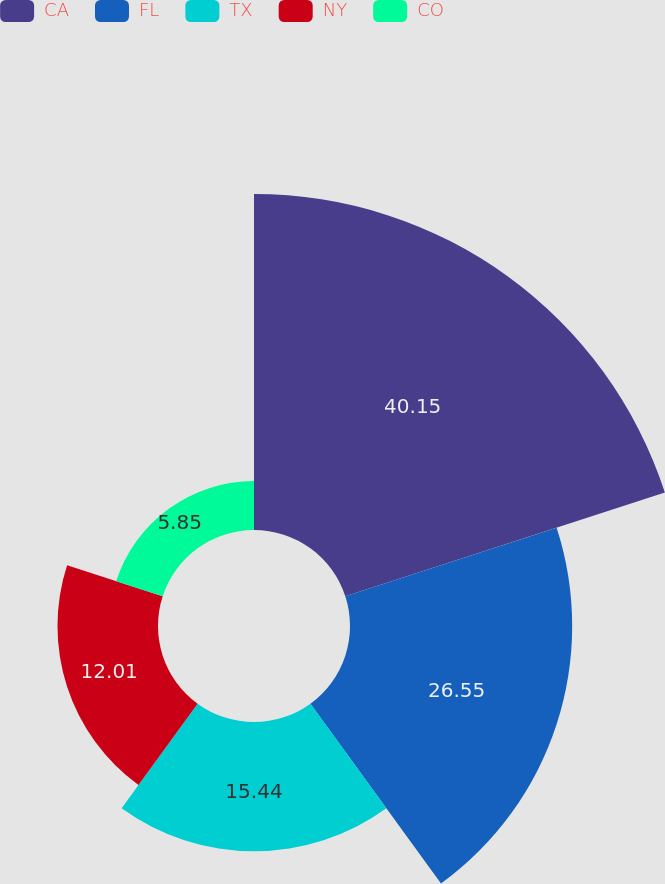Convert chart to OTSL. <chart><loc_0><loc_0><loc_500><loc_500><pie_chart><fcel>CA<fcel>FL<fcel>TX<fcel>NY<fcel>CO<nl><fcel>40.15%<fcel>26.55%<fcel>15.44%<fcel>12.01%<fcel>5.85%<nl></chart> 